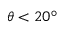<formula> <loc_0><loc_0><loc_500><loc_500>\theta < 2 0 ^ { \circ }</formula> 